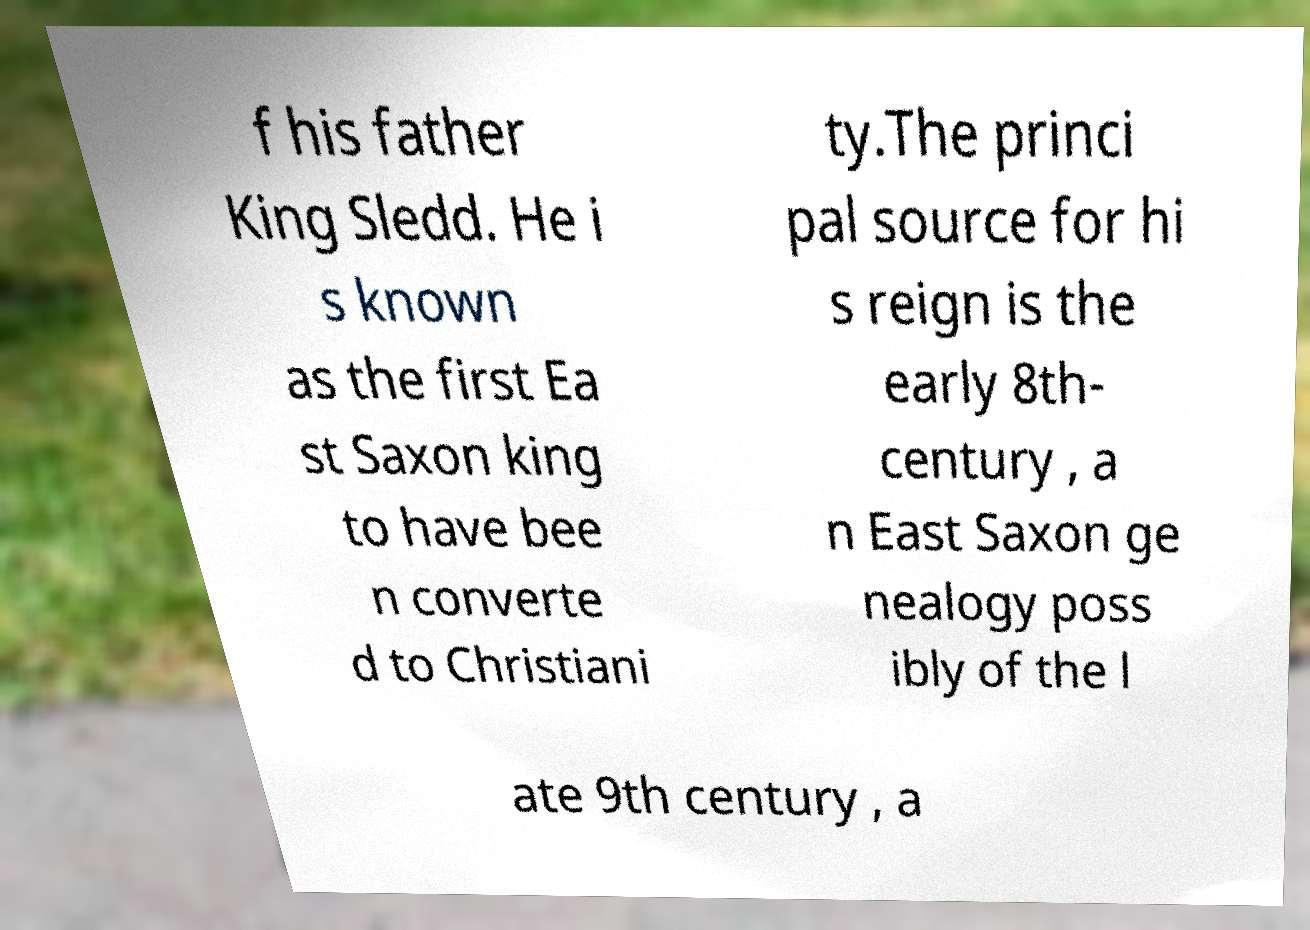Could you assist in decoding the text presented in this image and type it out clearly? f his father King Sledd. He i s known as the first Ea st Saxon king to have bee n converte d to Christiani ty.The princi pal source for hi s reign is the early 8th- century , a n East Saxon ge nealogy poss ibly of the l ate 9th century , a 